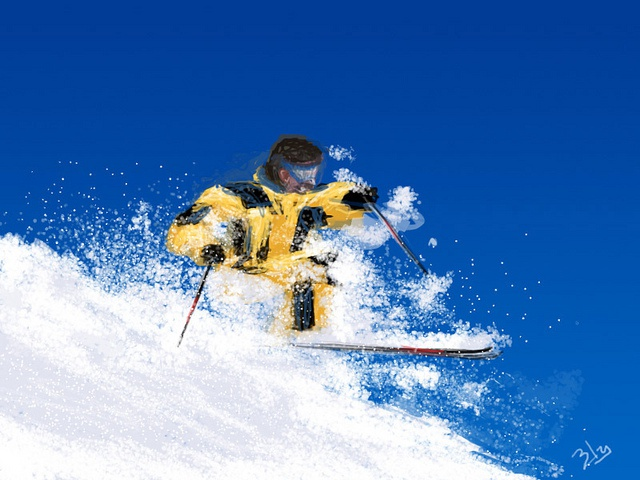Describe the objects in this image and their specific colors. I can see people in darkblue, black, khaki, gold, and ivory tones and skis in darkblue, darkgray, gray, and lavender tones in this image. 